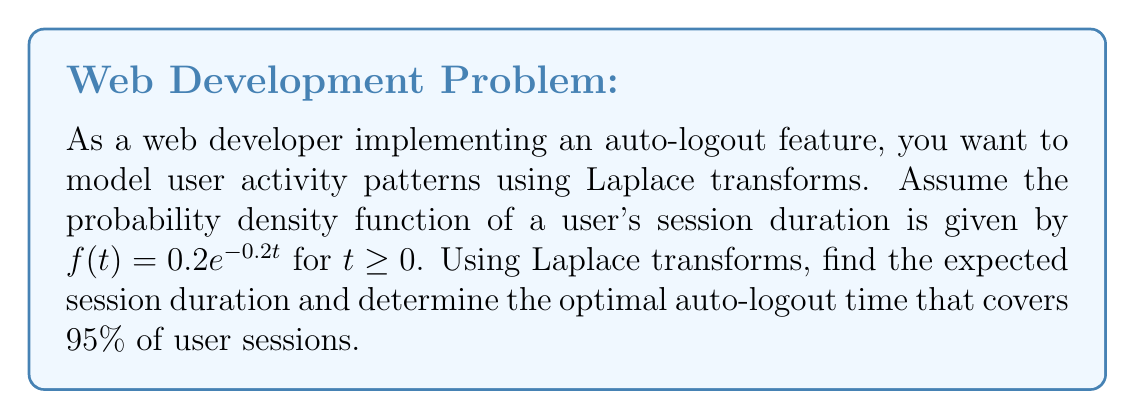Help me with this question. To solve this problem, we'll use Laplace transforms and their properties:

1. First, let's find the Laplace transform of $f(t)$:
   $$\mathcal{L}\{f(t)\} = F(s) = \int_0^\infty 0.2e^{-0.2t} e^{-st} dt = \frac{0.2}{s + 0.2}$$

2. To find the expected session duration, we can use the property that the negative of the derivative of $F(s)$ at $s=0$ gives the expected value of $t$:
   $$E[t] = -\frac{d}{ds}F(s)\bigg|_{s=0} = -\frac{d}{ds}\left(\frac{0.2}{s + 0.2}\right)\bigg|_{s=0}$$
   $$= \frac{0.2}{(s + 0.2)^2}\bigg|_{s=0} = \frac{0.2}{(0.2)^2} = 5$$

   So, the expected session duration is 5 time units (e.g., minutes).

3. To find the optimal auto-logout time covering 95% of sessions, we need to solve:
   $$\int_0^T 0.2e^{-0.2t} dt = 0.95$$

   Using the cumulative distribution function:
   $$1 - e^{-0.2T} = 0.95$$
   $$e^{-0.2T} = 0.05$$
   $$-0.2T = \ln(0.05)$$
   $$T = -\frac{\ln(0.05)}{0.2} \approx 14.98$$

Therefore, the optimal auto-logout time covering 95% of user sessions is approximately 14.98 time units.
Answer: The expected session duration is 5 time units, and the optimal auto-logout time covering 95% of user sessions is approximately 14.98 time units. 